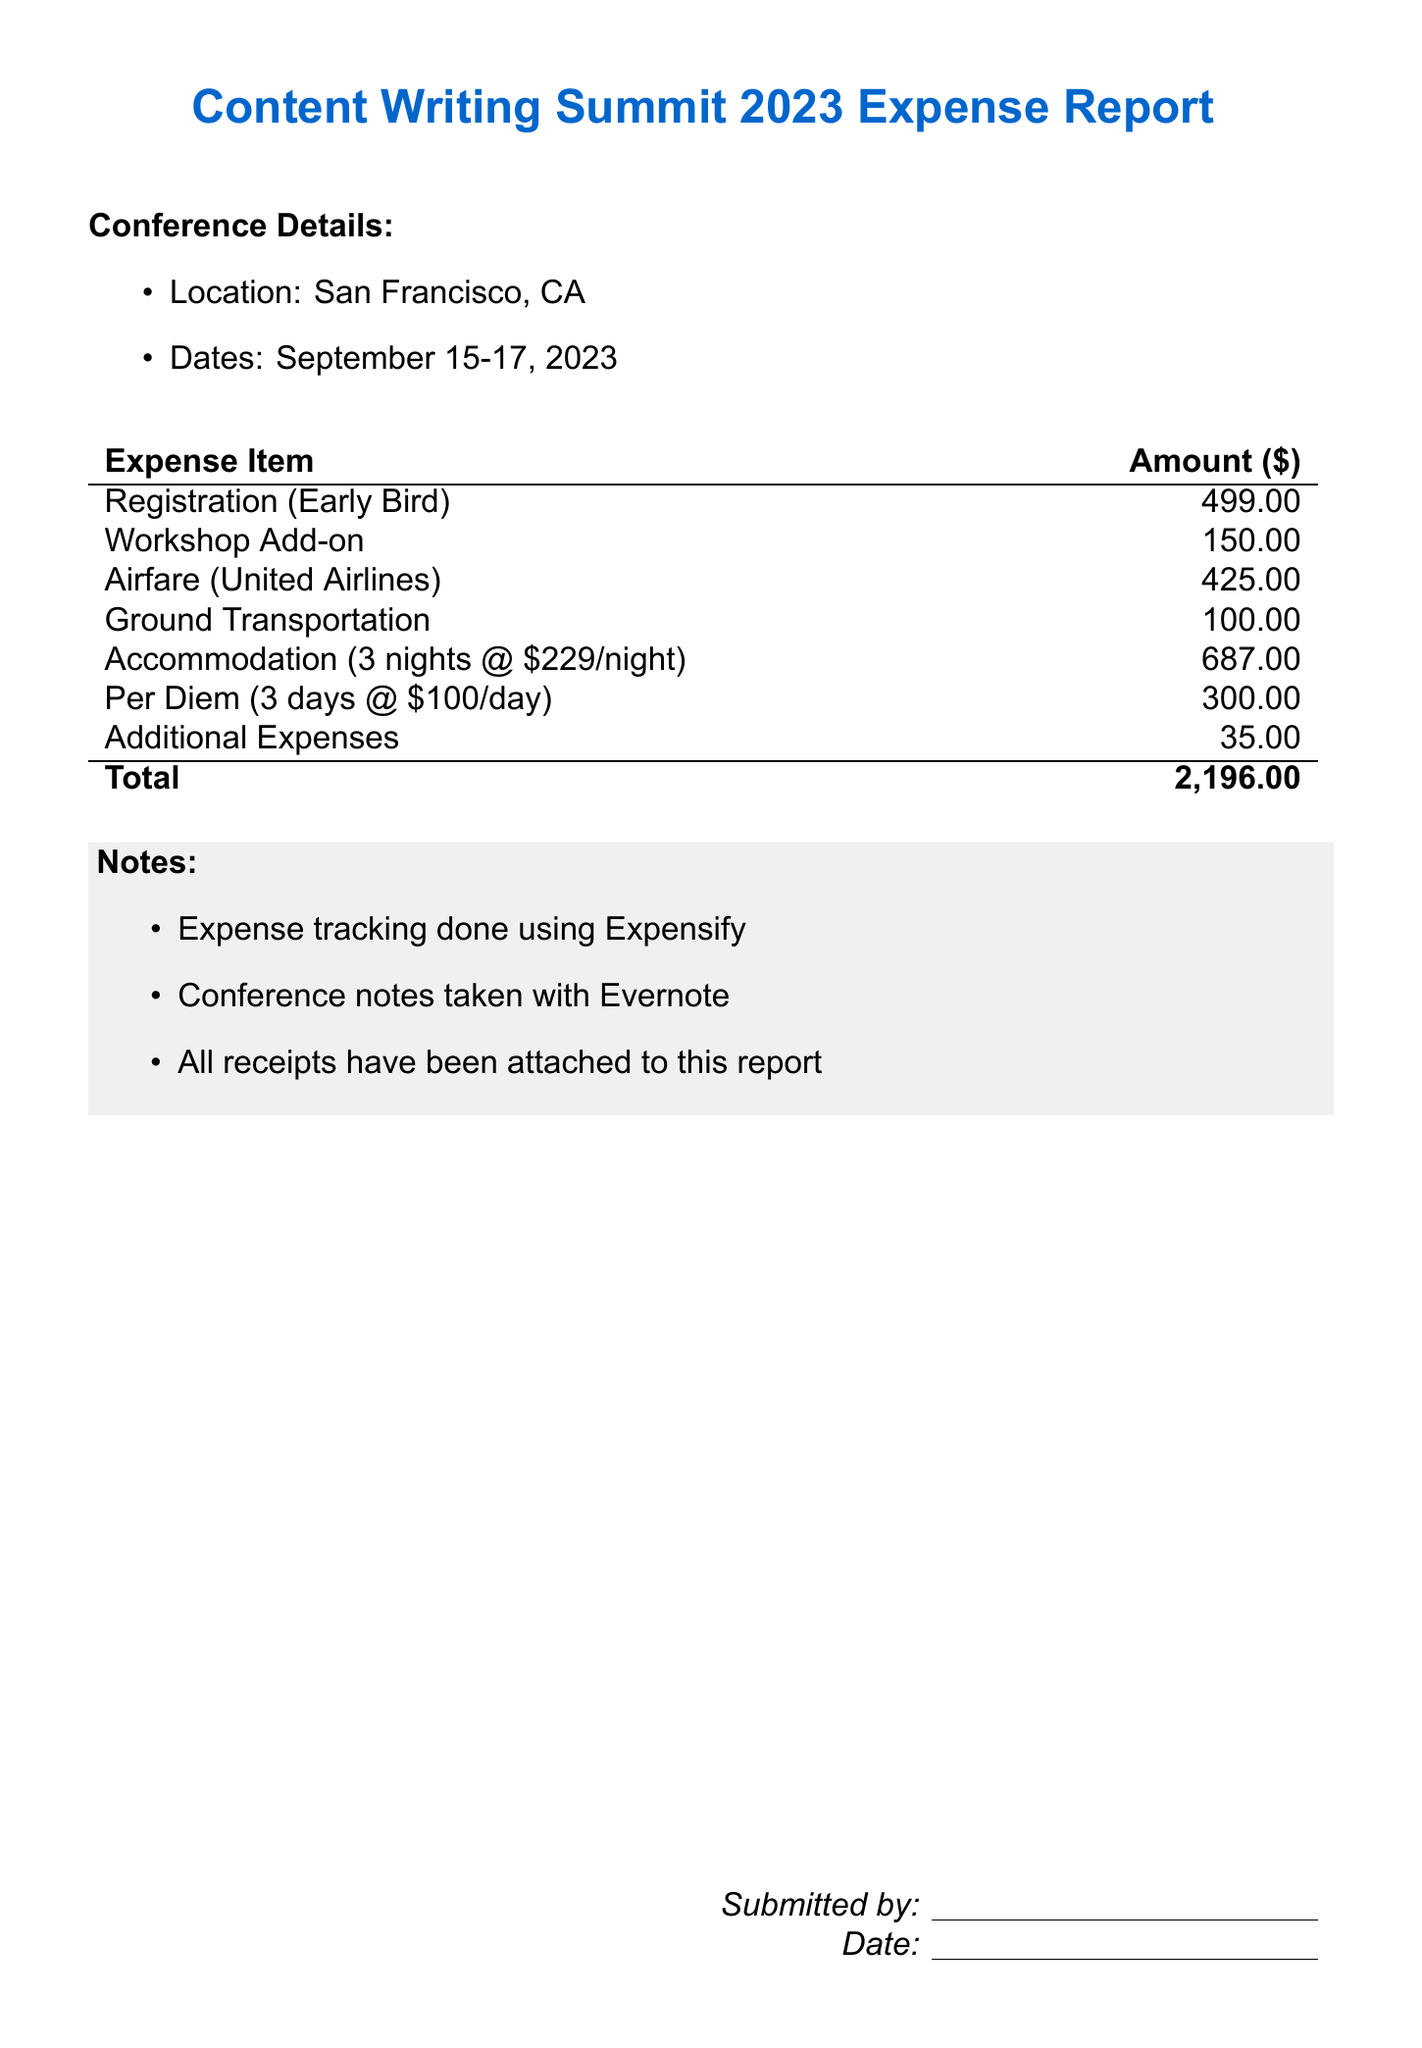What is the total expense amount? The total expense amount is found in the summary of expenses at the bottom of the expense report.
Answer: 2,196.00 What is the date range of the conference? The date range of the conference is specified directly in the document under the Conference Details section.
Answer: September 15-17, 2023 How much was paid for accommodation? The amount for accommodation can be found in the expense item details within the table.
Answer: 687.00 How much is the per diem per day? The per diem per day is detailed in the expense breakdown.
Answer: 100.00 Which airline was used for airfare? The document specifies the airline used for airfare in the expense item section.
Answer: United Airlines What is the cost of the workshop add-on? The cost of the workshop add-on is provided alongside the other expenses in the table.
Answer: 150.00 What platforms were used for expense tracking and note-taking? The document lists the platforms used for expense tracking and note-taking in the notes section.
Answer: Expensify and Evernote How many nights of accommodation were billed? The number of nights billed for accommodation is indicated in the expense details of the report.
Answer: 3 nights What is indicated as an "Additional Expense"? The "Additional Expenses" line item identifies other miscellaneous costs incurred during the conference.
Answer: 35.00 